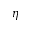Convert formula to latex. <formula><loc_0><loc_0><loc_500><loc_500>\eta</formula> 